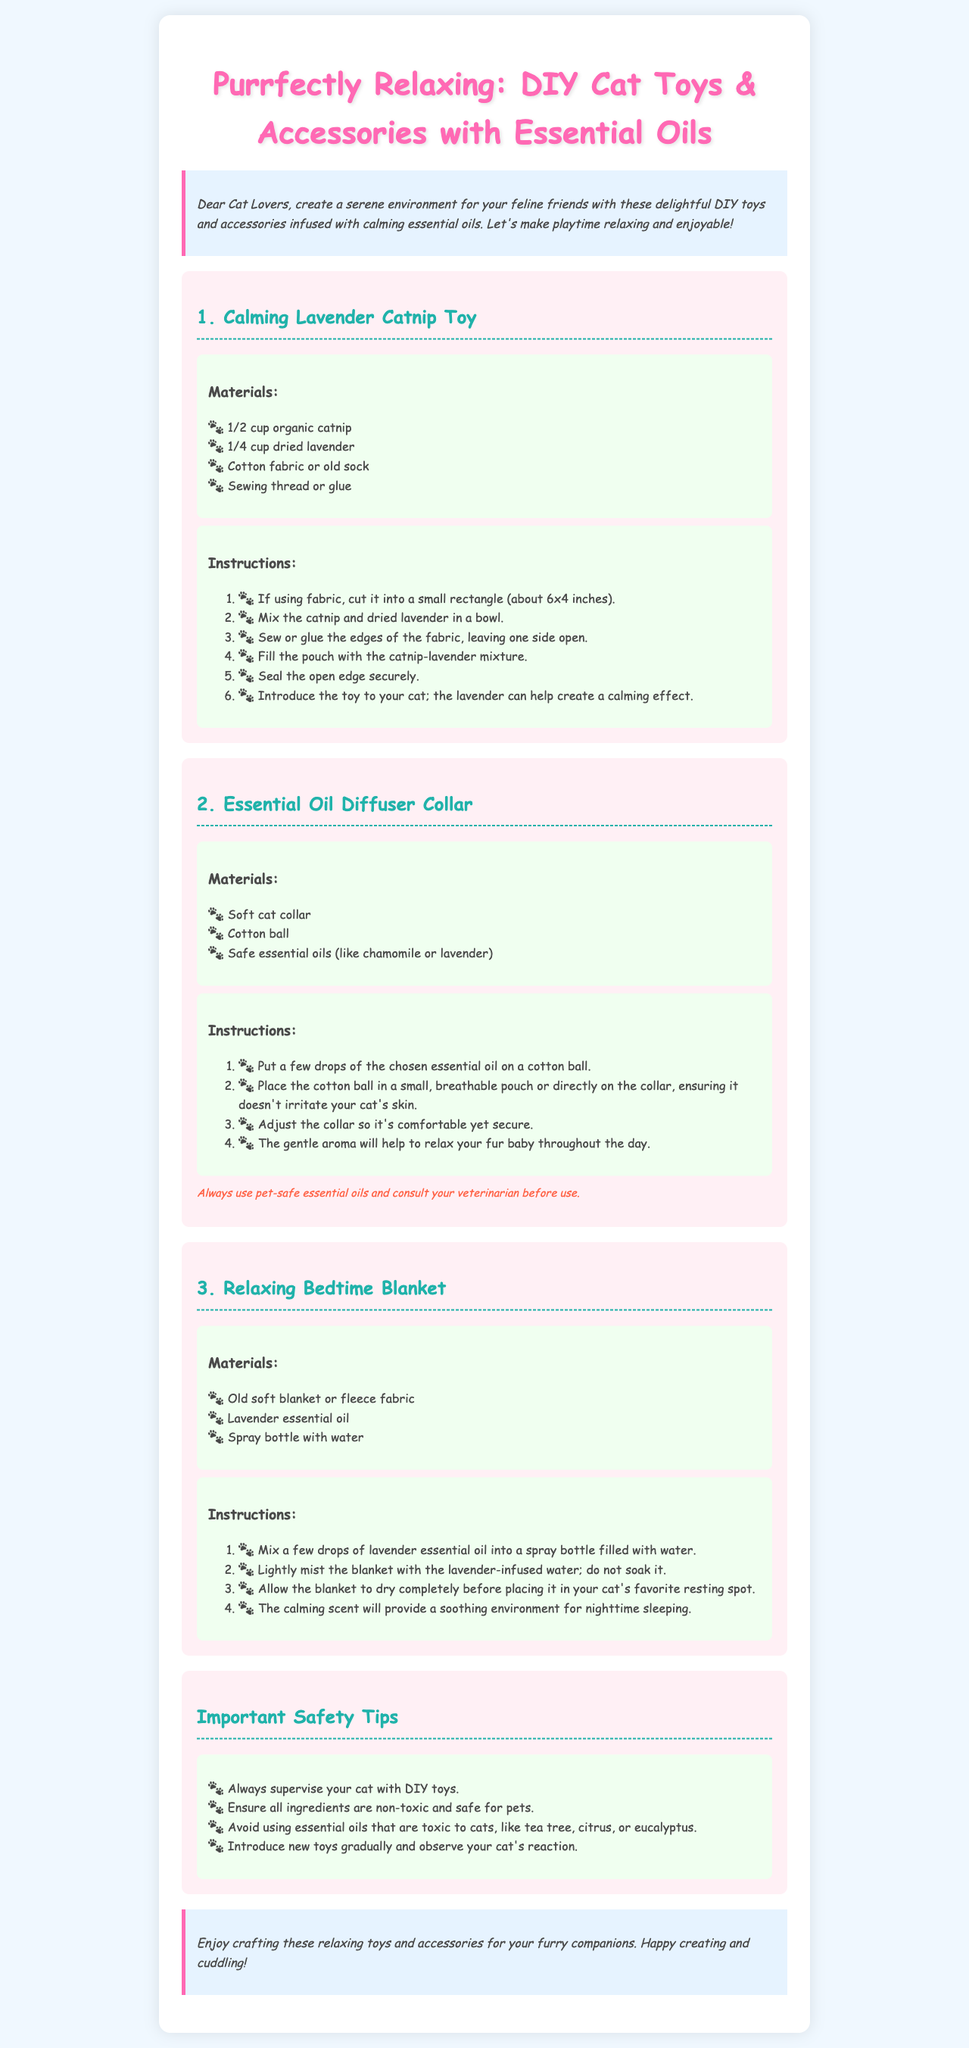What is the title of the newsletter? The title of the newsletter is stated in the header section of the document.
Answer: Purrfectly Relaxing: DIY Cat Toys & Accessories with Essential Oils How many toys are featured in the document? The document lists three separate toy projects for DIY crafting.
Answer: 3 What essential oil is used in the Relaxing Bedtime Blanket? The specific essential oil mentioned for use in the blanket is found in the materials section.
Answer: Lavender What type of collar is suggested for the Essential Oil Diffuser Collar project? The materials section specifies the type of collar needed for this project.
Answer: Soft cat collar What is the first step in making the Calming Lavender Catnip Toy? The instructions for making the toy outline the specific first action to take.
Answer: Cut fabric What materials are needed for the Essential Oil Diffuser Collar? The materials list indicates what is required to create this collar.
Answer: Soft cat collar, cotton ball, safe essential oils Why should you consult a veterinarian before using essential oils? The note provided with the diffuser collar emphasizes the importance of safety regarding pets.
Answer: Safety assurance What should be done before introducing new toys to cats? The tips section provides a precaution regarding new toys and their introduction.
Answer: Observe reaction 